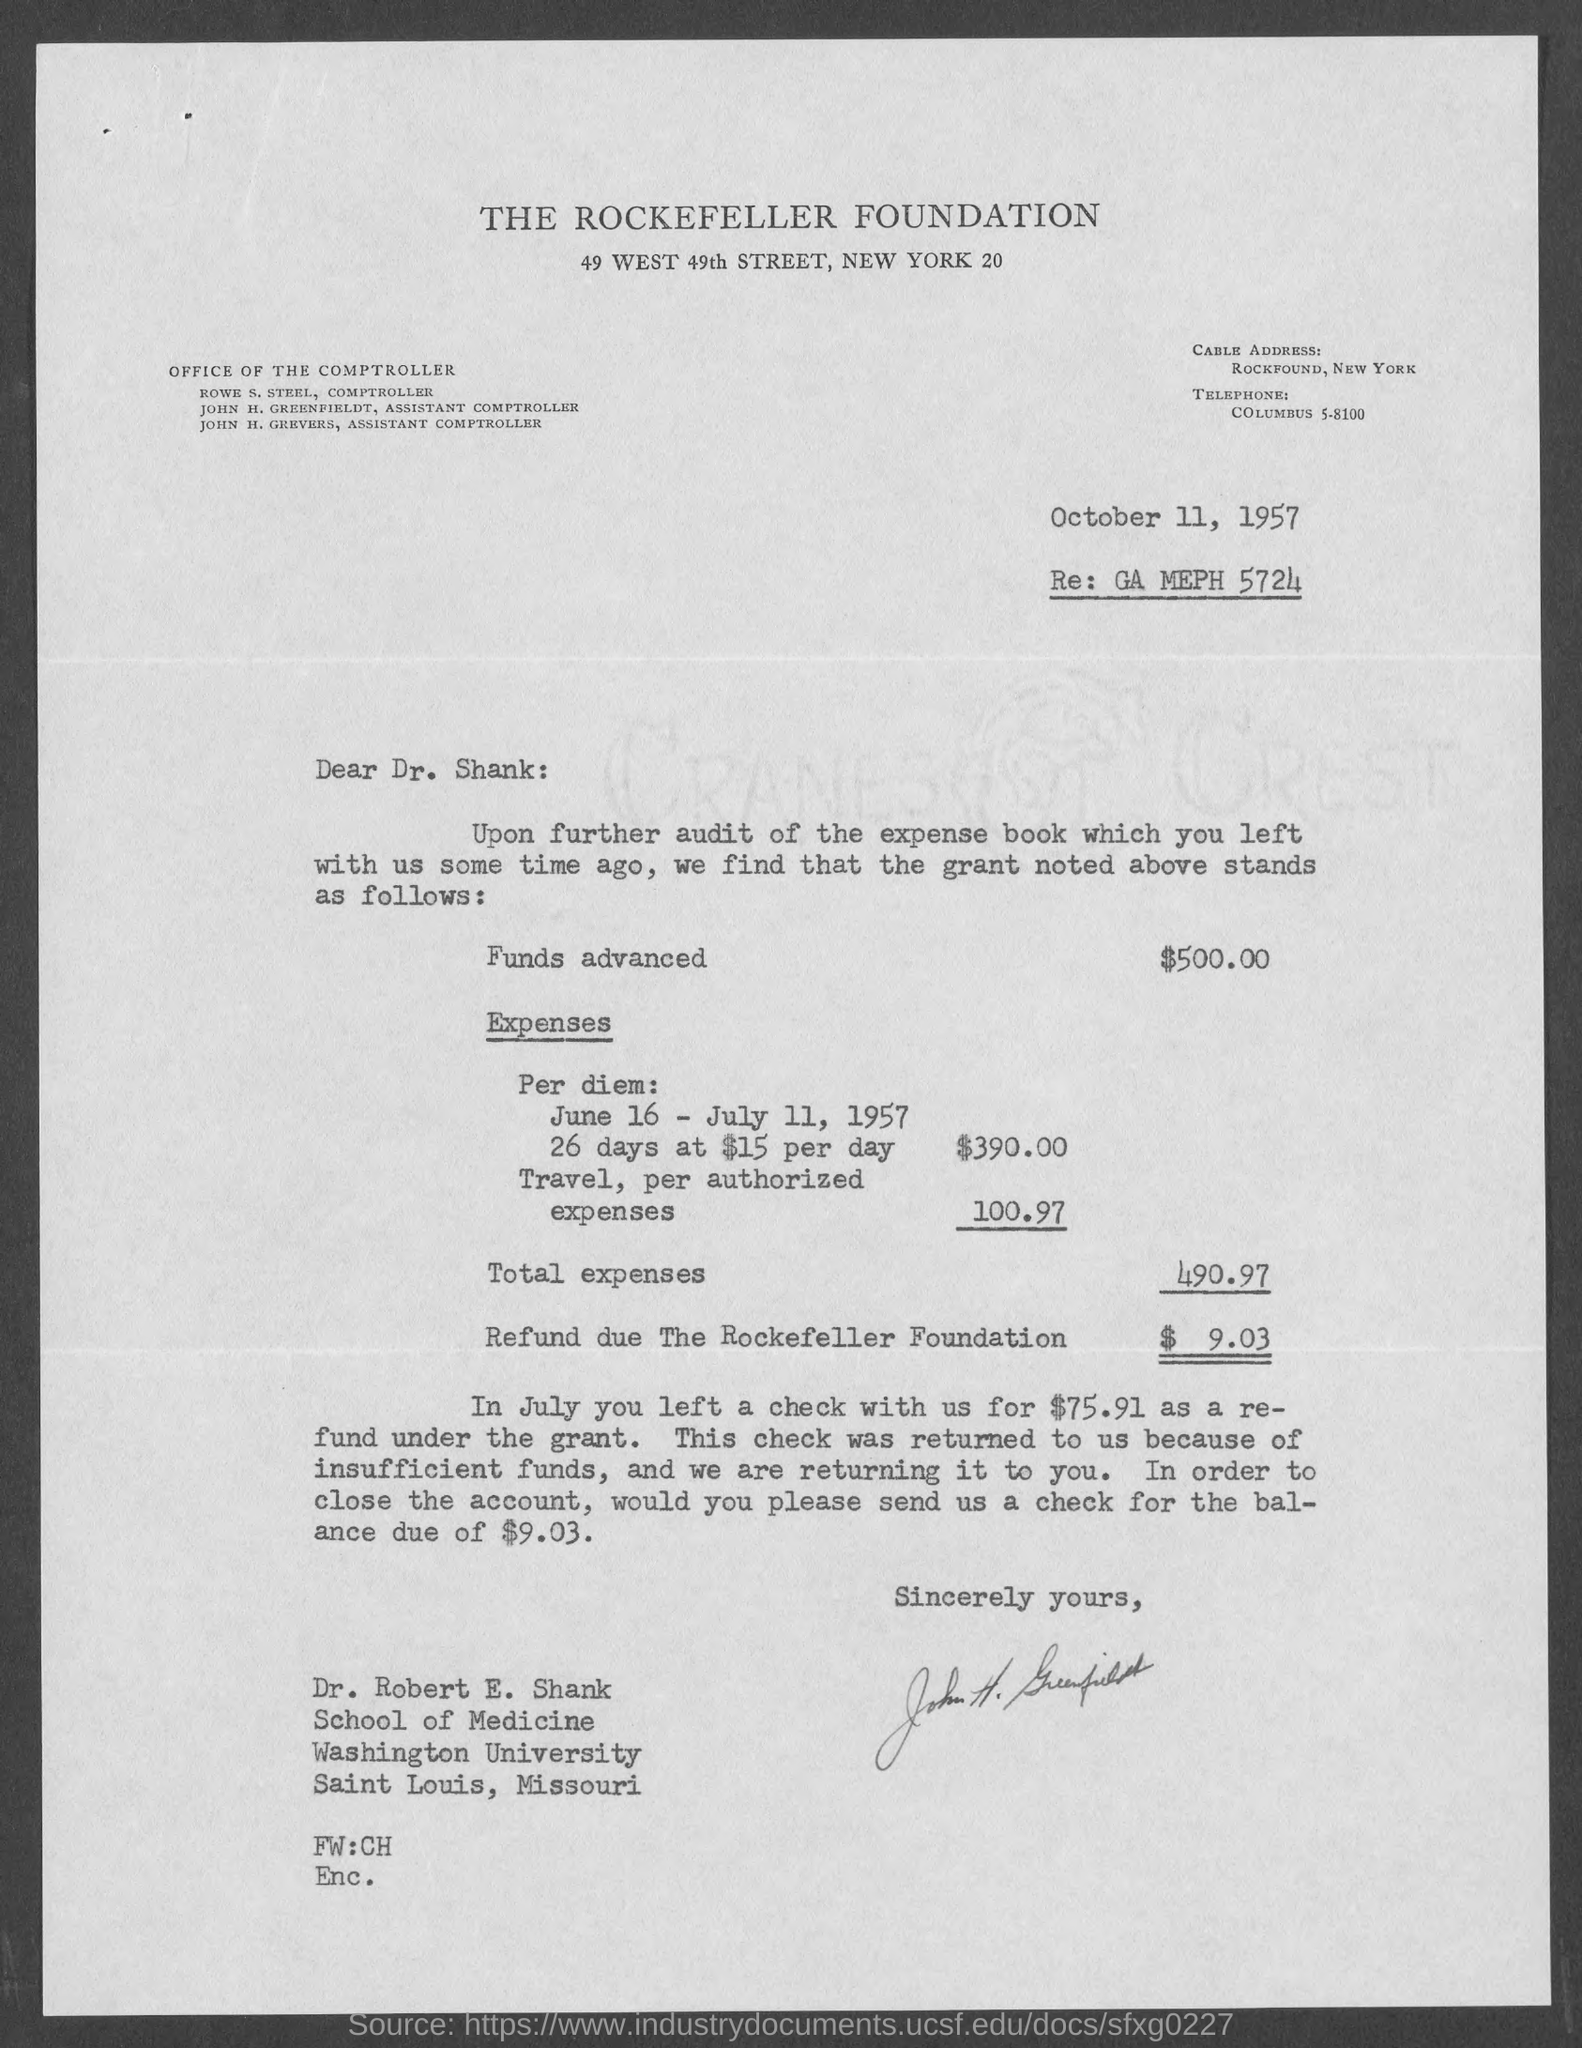When is the document dated?
Your answer should be very brief. October 11, 1957. What is written after Re:?
Your response must be concise. GA MEPH 5724. How much are the funds advanced?
Offer a very short reply. $500.00. How much is the Refund due The Rockefeller Foundation?
Offer a very short reply. $9.03. 